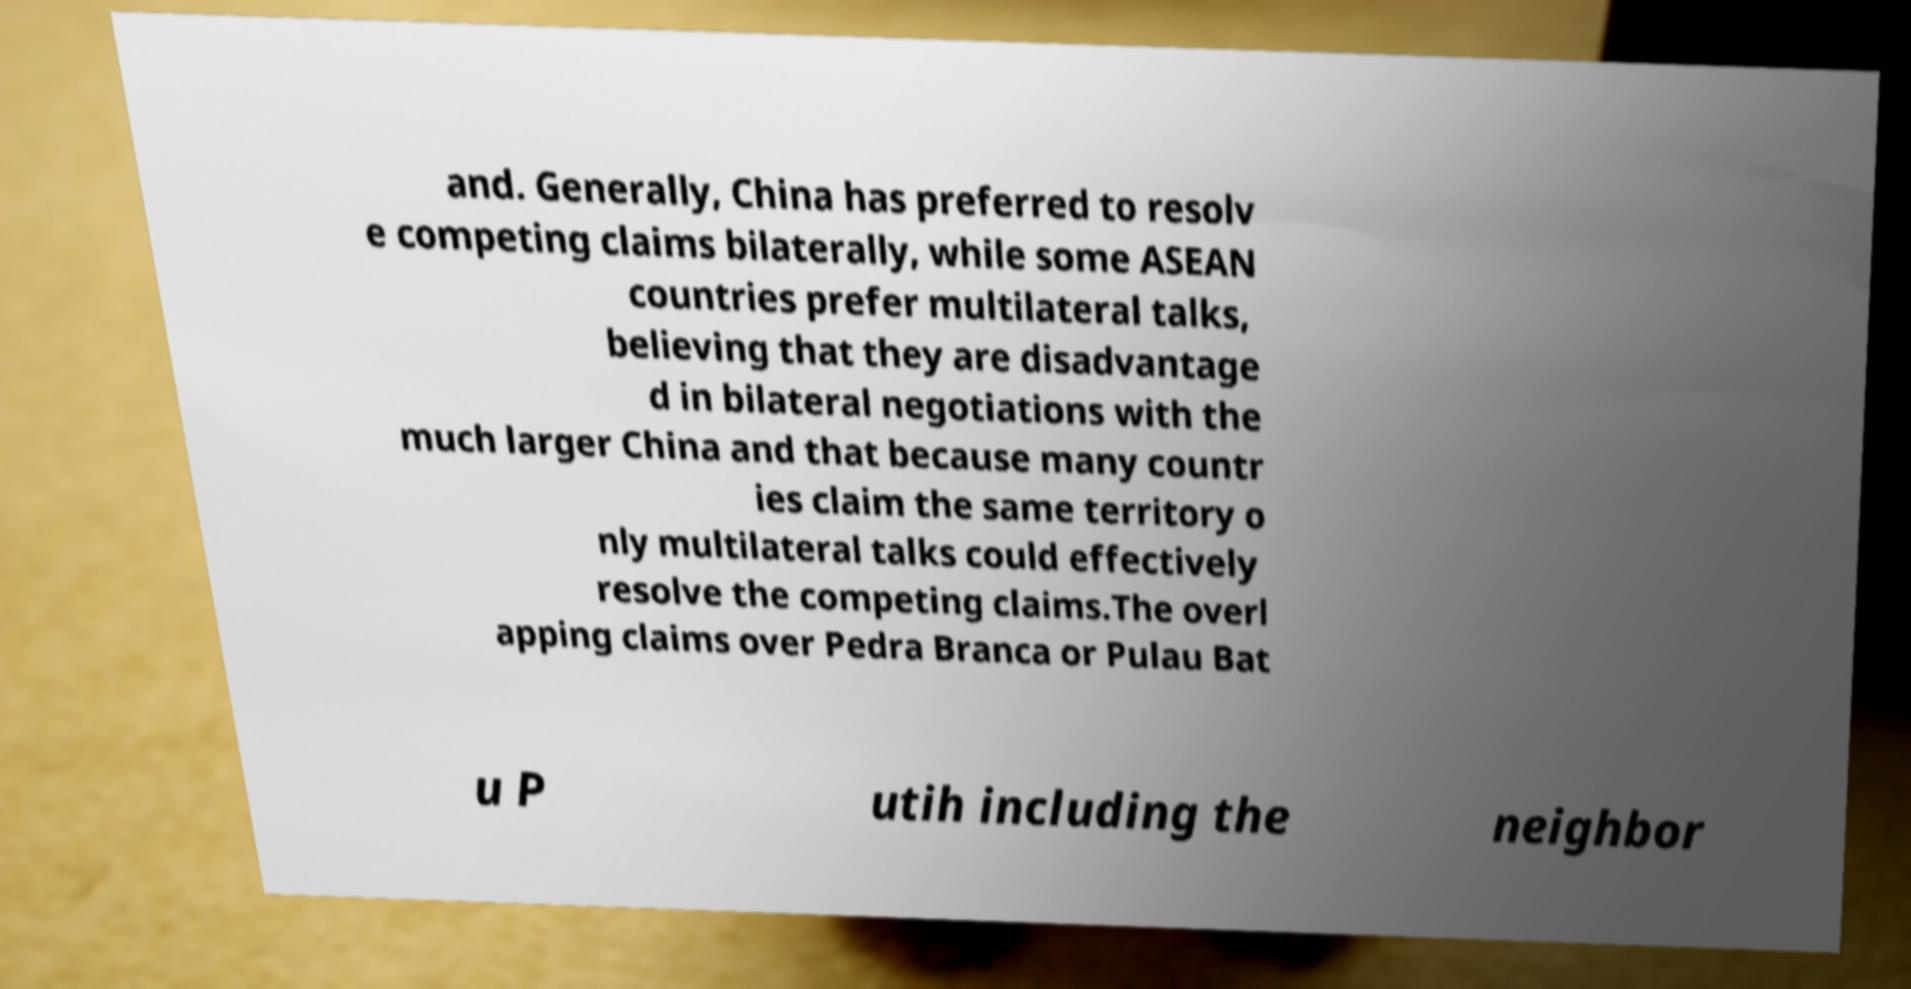Can you read and provide the text displayed in the image?This photo seems to have some interesting text. Can you extract and type it out for me? and. Generally, China has preferred to resolv e competing claims bilaterally, while some ASEAN countries prefer multilateral talks, believing that they are disadvantage d in bilateral negotiations with the much larger China and that because many countr ies claim the same territory o nly multilateral talks could effectively resolve the competing claims.The overl apping claims over Pedra Branca or Pulau Bat u P utih including the neighbor 